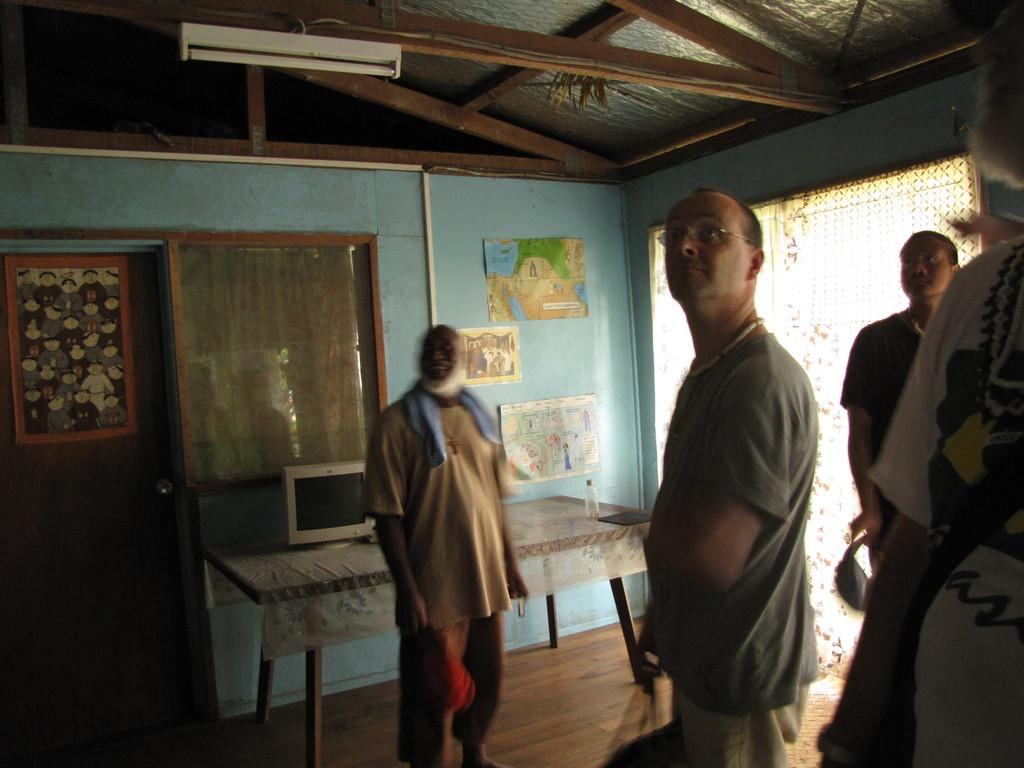What is the primary subject of the image? The primary subject of the image is men. What are the men doing in the image? The men are standing in the image. What are the men looking at in the image? The men are looking at a roof in the image. What type of structure does the roof belong to? The roof is part of a house. What is the tax rate on the legs visible in the image? There are no legs visible in the image, and tax rates are not applicable to body parts. 